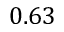<formula> <loc_0><loc_0><loc_500><loc_500>0 . 6 3</formula> 